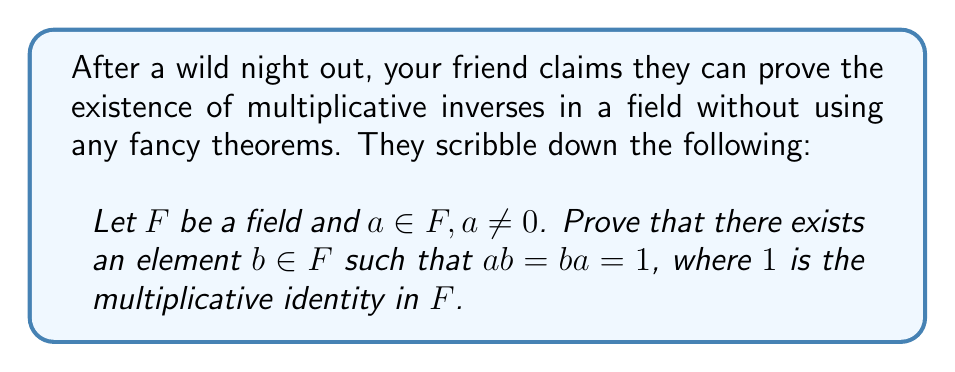Can you answer this question? Let's prove this step-by-step:

1) First, consider the set $S = \{ax : x \in F\}$. This is the set of all elements in $F$ multiplied by $a$.

2) Since $a \neq 0$ and $F$ is a field, $S$ is non-empty (it contains at least $a \cdot 1 = a$).

3) Now, we claim that $0 \notin S$. If $0 \in S$, then there would exist some $y \in F$ such that $ay = 0$. But in a field, this is only possible if $a = 0$ or $y = 0$. Since $a \neq 0$ by assumption, we must have $y = 0$. But then $ay = a \cdot 0 = 0$, contradicting $a \neq 0$.

4) Since $0 \notin S$ and $S \subseteq F$, we know that $S$ is a non-empty subset of the non-zero elements of $F$.

5) In a field, the non-zero elements form a group under multiplication. One property of groups is that they have no proper non-empty subgroups.

6) Therefore, $S$ must be the entire set of non-zero elements of $F$.

7) Since $1 \in F$ and $1 \neq 0$, we know that $1 \in S$.

8) By the definition of $S$, if $1 \in S$, there must exist some $b \in F$ such that $ab = 1$.

9) To show that $ba = 1$ as well, we can multiply both sides of $ab = 1$ by $b$ on the left:
   $b(ab) = b1 = b$
   $(ba)b = b$
   
   Since $b \neq 0$ (as $ab = 1$), we can cancel $b$ from both sides, getting $ba = 1$.

Thus, we have shown that there exists $b \in F$ such that $ab = ba = 1$.
Answer: $\exists b \in F : ab = ba = 1$ 